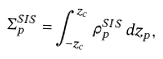<formula> <loc_0><loc_0><loc_500><loc_500>\Sigma _ { p } ^ { S I S } = \int _ { - z _ { c } } ^ { z _ { c } } \, \rho _ { p } ^ { S I S } \, d z _ { p } ,</formula> 